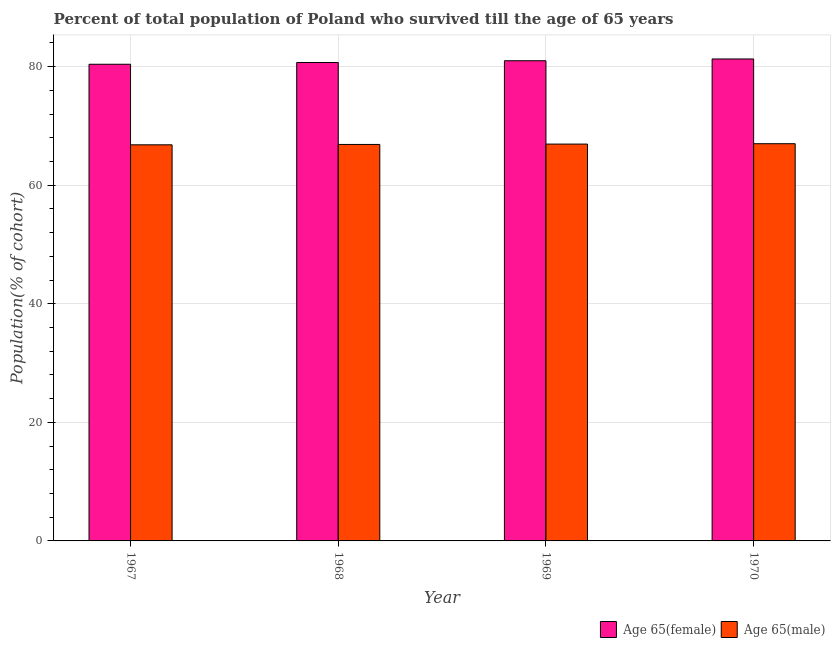How many groups of bars are there?
Offer a terse response. 4. Are the number of bars per tick equal to the number of legend labels?
Your answer should be very brief. Yes. Are the number of bars on each tick of the X-axis equal?
Your answer should be compact. Yes. How many bars are there on the 3rd tick from the left?
Ensure brevity in your answer.  2. How many bars are there on the 1st tick from the right?
Ensure brevity in your answer.  2. What is the label of the 3rd group of bars from the left?
Ensure brevity in your answer.  1969. What is the percentage of male population who survived till age of 65 in 1968?
Ensure brevity in your answer.  66.87. Across all years, what is the maximum percentage of male population who survived till age of 65?
Provide a succinct answer. 66.99. Across all years, what is the minimum percentage of male population who survived till age of 65?
Your answer should be very brief. 66.81. In which year was the percentage of male population who survived till age of 65 maximum?
Your response must be concise. 1970. In which year was the percentage of female population who survived till age of 65 minimum?
Ensure brevity in your answer.  1967. What is the total percentage of male population who survived till age of 65 in the graph?
Ensure brevity in your answer.  267.6. What is the difference between the percentage of male population who survived till age of 65 in 1967 and that in 1969?
Keep it short and to the point. -0.13. What is the difference between the percentage of male population who survived till age of 65 in 1968 and the percentage of female population who survived till age of 65 in 1970?
Provide a short and direct response. -0.13. What is the average percentage of male population who survived till age of 65 per year?
Provide a short and direct response. 66.9. In how many years, is the percentage of male population who survived till age of 65 greater than 28 %?
Offer a terse response. 4. What is the ratio of the percentage of female population who survived till age of 65 in 1967 to that in 1970?
Ensure brevity in your answer.  0.99. Is the percentage of male population who survived till age of 65 in 1969 less than that in 1970?
Offer a terse response. Yes. Is the difference between the percentage of male population who survived till age of 65 in 1968 and 1969 greater than the difference between the percentage of female population who survived till age of 65 in 1968 and 1969?
Ensure brevity in your answer.  No. What is the difference between the highest and the second highest percentage of male population who survived till age of 65?
Your answer should be compact. 0.06. What is the difference between the highest and the lowest percentage of male population who survived till age of 65?
Make the answer very short. 0.19. In how many years, is the percentage of female population who survived till age of 65 greater than the average percentage of female population who survived till age of 65 taken over all years?
Keep it short and to the point. 2. Is the sum of the percentage of male population who survived till age of 65 in 1967 and 1968 greater than the maximum percentage of female population who survived till age of 65 across all years?
Provide a short and direct response. Yes. What does the 1st bar from the left in 1967 represents?
Make the answer very short. Age 65(female). What does the 2nd bar from the right in 1969 represents?
Ensure brevity in your answer.  Age 65(female). Are all the bars in the graph horizontal?
Your answer should be compact. No. Are the values on the major ticks of Y-axis written in scientific E-notation?
Provide a succinct answer. No. Does the graph contain grids?
Your response must be concise. Yes. How are the legend labels stacked?
Provide a succinct answer. Horizontal. What is the title of the graph?
Your answer should be very brief. Percent of total population of Poland who survived till the age of 65 years. What is the label or title of the X-axis?
Give a very brief answer. Year. What is the label or title of the Y-axis?
Offer a terse response. Population(% of cohort). What is the Population(% of cohort) of Age 65(female) in 1967?
Your response must be concise. 80.39. What is the Population(% of cohort) in Age 65(male) in 1967?
Offer a very short reply. 66.81. What is the Population(% of cohort) in Age 65(female) in 1968?
Keep it short and to the point. 80.69. What is the Population(% of cohort) in Age 65(male) in 1968?
Offer a very short reply. 66.87. What is the Population(% of cohort) in Age 65(female) in 1969?
Ensure brevity in your answer.  80.99. What is the Population(% of cohort) in Age 65(male) in 1969?
Ensure brevity in your answer.  66.93. What is the Population(% of cohort) of Age 65(female) in 1970?
Ensure brevity in your answer.  81.29. What is the Population(% of cohort) of Age 65(male) in 1970?
Ensure brevity in your answer.  66.99. Across all years, what is the maximum Population(% of cohort) of Age 65(female)?
Provide a succinct answer. 81.29. Across all years, what is the maximum Population(% of cohort) in Age 65(male)?
Your answer should be very brief. 66.99. Across all years, what is the minimum Population(% of cohort) of Age 65(female)?
Offer a very short reply. 80.39. Across all years, what is the minimum Population(% of cohort) of Age 65(male)?
Your response must be concise. 66.81. What is the total Population(% of cohort) in Age 65(female) in the graph?
Keep it short and to the point. 323.36. What is the total Population(% of cohort) of Age 65(male) in the graph?
Your answer should be compact. 267.6. What is the difference between the Population(% of cohort) of Age 65(female) in 1967 and that in 1968?
Make the answer very short. -0.3. What is the difference between the Population(% of cohort) in Age 65(male) in 1967 and that in 1968?
Offer a very short reply. -0.06. What is the difference between the Population(% of cohort) in Age 65(female) in 1967 and that in 1969?
Make the answer very short. -0.59. What is the difference between the Population(% of cohort) in Age 65(male) in 1967 and that in 1969?
Offer a very short reply. -0.13. What is the difference between the Population(% of cohort) in Age 65(female) in 1967 and that in 1970?
Offer a very short reply. -0.89. What is the difference between the Population(% of cohort) of Age 65(male) in 1967 and that in 1970?
Ensure brevity in your answer.  -0.19. What is the difference between the Population(% of cohort) in Age 65(female) in 1968 and that in 1969?
Ensure brevity in your answer.  -0.3. What is the difference between the Population(% of cohort) in Age 65(male) in 1968 and that in 1969?
Provide a short and direct response. -0.06. What is the difference between the Population(% of cohort) in Age 65(female) in 1968 and that in 1970?
Keep it short and to the point. -0.59. What is the difference between the Population(% of cohort) in Age 65(male) in 1968 and that in 1970?
Provide a succinct answer. -0.13. What is the difference between the Population(% of cohort) in Age 65(female) in 1969 and that in 1970?
Offer a very short reply. -0.3. What is the difference between the Population(% of cohort) in Age 65(male) in 1969 and that in 1970?
Your response must be concise. -0.06. What is the difference between the Population(% of cohort) in Age 65(female) in 1967 and the Population(% of cohort) in Age 65(male) in 1968?
Make the answer very short. 13.53. What is the difference between the Population(% of cohort) in Age 65(female) in 1967 and the Population(% of cohort) in Age 65(male) in 1969?
Offer a very short reply. 13.46. What is the difference between the Population(% of cohort) of Age 65(female) in 1968 and the Population(% of cohort) of Age 65(male) in 1969?
Offer a very short reply. 13.76. What is the difference between the Population(% of cohort) in Age 65(female) in 1968 and the Population(% of cohort) in Age 65(male) in 1970?
Provide a succinct answer. 13.7. What is the difference between the Population(% of cohort) of Age 65(female) in 1969 and the Population(% of cohort) of Age 65(male) in 1970?
Provide a short and direct response. 13.99. What is the average Population(% of cohort) in Age 65(female) per year?
Give a very brief answer. 80.84. What is the average Population(% of cohort) of Age 65(male) per year?
Give a very brief answer. 66.9. In the year 1967, what is the difference between the Population(% of cohort) of Age 65(female) and Population(% of cohort) of Age 65(male)?
Ensure brevity in your answer.  13.59. In the year 1968, what is the difference between the Population(% of cohort) of Age 65(female) and Population(% of cohort) of Age 65(male)?
Ensure brevity in your answer.  13.82. In the year 1969, what is the difference between the Population(% of cohort) in Age 65(female) and Population(% of cohort) in Age 65(male)?
Provide a short and direct response. 14.06. In the year 1970, what is the difference between the Population(% of cohort) of Age 65(female) and Population(% of cohort) of Age 65(male)?
Provide a short and direct response. 14.29. What is the ratio of the Population(% of cohort) in Age 65(female) in 1967 to that in 1968?
Provide a succinct answer. 1. What is the ratio of the Population(% of cohort) of Age 65(female) in 1968 to that in 1970?
Make the answer very short. 0.99. What is the ratio of the Population(% of cohort) in Age 65(male) in 1968 to that in 1970?
Give a very brief answer. 1. What is the ratio of the Population(% of cohort) of Age 65(female) in 1969 to that in 1970?
Offer a very short reply. 1. What is the difference between the highest and the second highest Population(% of cohort) of Age 65(female)?
Provide a succinct answer. 0.3. What is the difference between the highest and the second highest Population(% of cohort) in Age 65(male)?
Keep it short and to the point. 0.06. What is the difference between the highest and the lowest Population(% of cohort) of Age 65(female)?
Offer a very short reply. 0.89. What is the difference between the highest and the lowest Population(% of cohort) of Age 65(male)?
Provide a short and direct response. 0.19. 